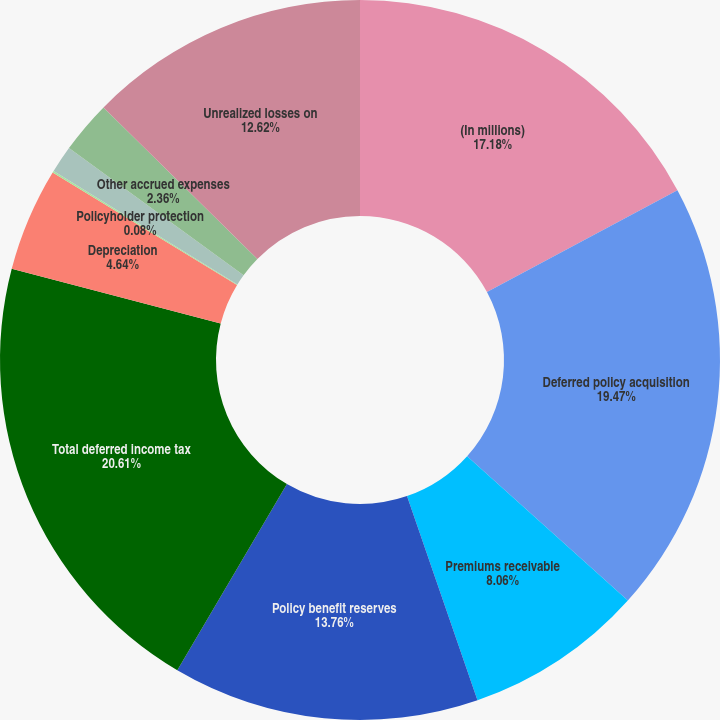<chart> <loc_0><loc_0><loc_500><loc_500><pie_chart><fcel>(In millions)<fcel>Deferred policy acquisition<fcel>Premiums receivable<fcel>Policy benefit reserves<fcel>Total deferred income tax<fcel>Depreciation<fcel>Policyholder protection<fcel>Unfunded retirement benefits<fcel>Other accrued expenses<fcel>Unrealized losses on<nl><fcel>17.18%<fcel>19.46%<fcel>8.06%<fcel>13.76%<fcel>20.6%<fcel>4.64%<fcel>0.08%<fcel>1.22%<fcel>2.36%<fcel>12.62%<nl></chart> 